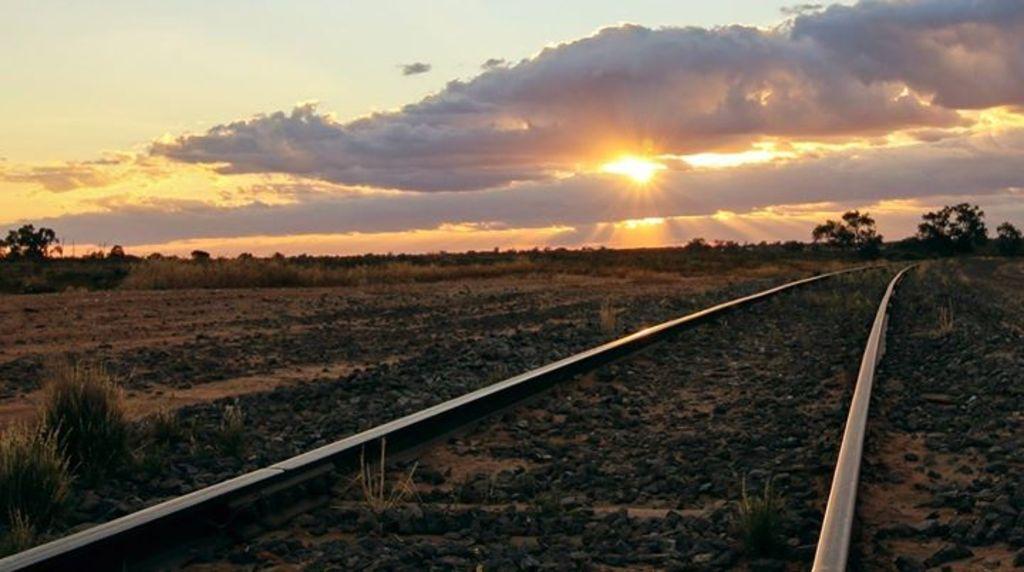Can you describe this image briefly? In this picture we can see the railway track. On the left we can see the farmland. In the background we can see many trees, grass and plants. At the top we can see sun, clouds and sky. 